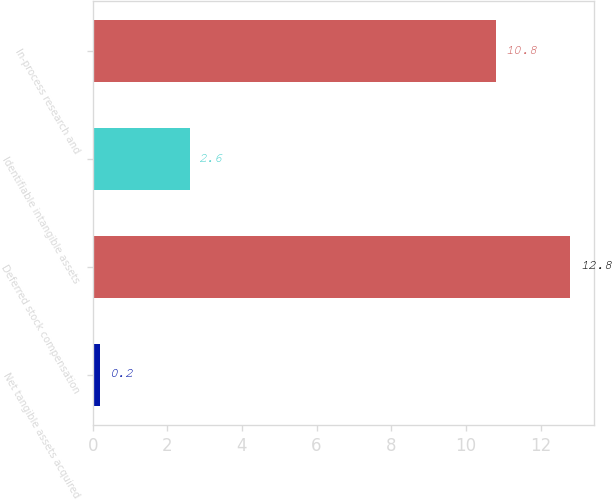<chart> <loc_0><loc_0><loc_500><loc_500><bar_chart><fcel>Net tangible assets acquired<fcel>Deferred stock compensation<fcel>Identifiable intangible assets<fcel>In-process research and<nl><fcel>0.2<fcel>12.8<fcel>2.6<fcel>10.8<nl></chart> 